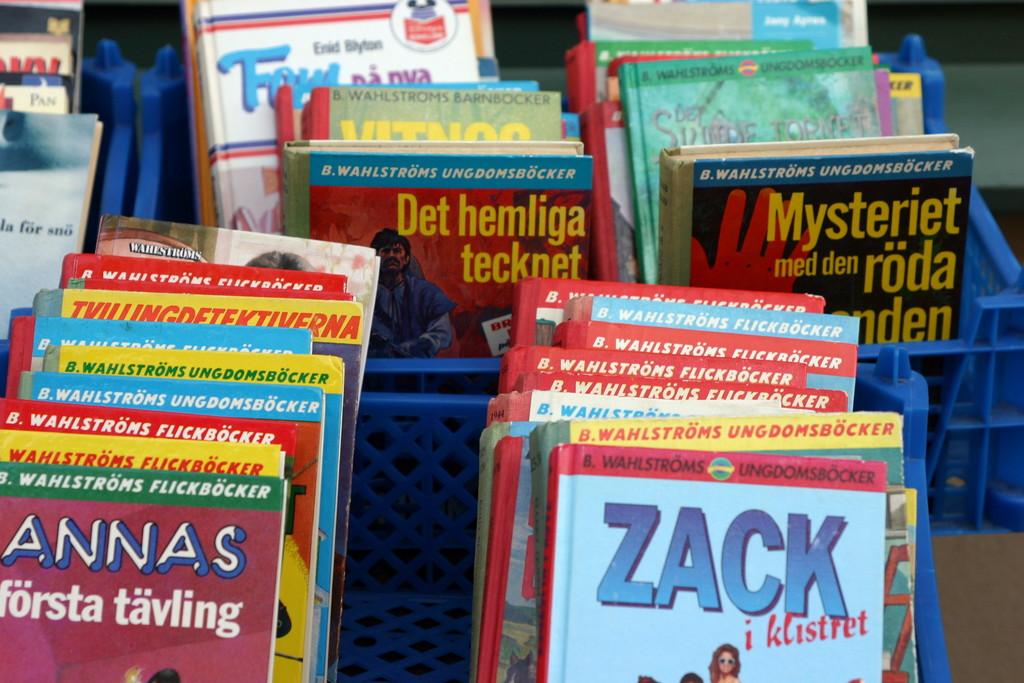What is the name on the blue book front right?
Your answer should be compact. Zack. 